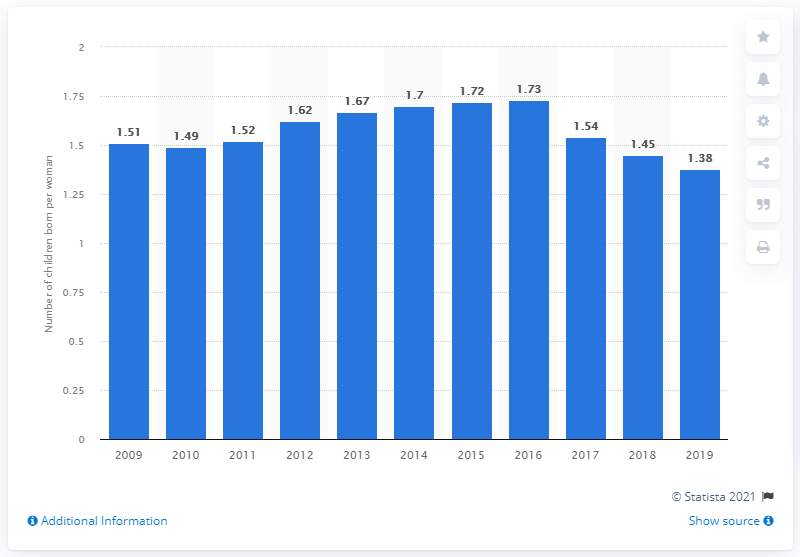Give some essential details in this illustration. In 2019, the fertility rate in Belarus was 1.38. 